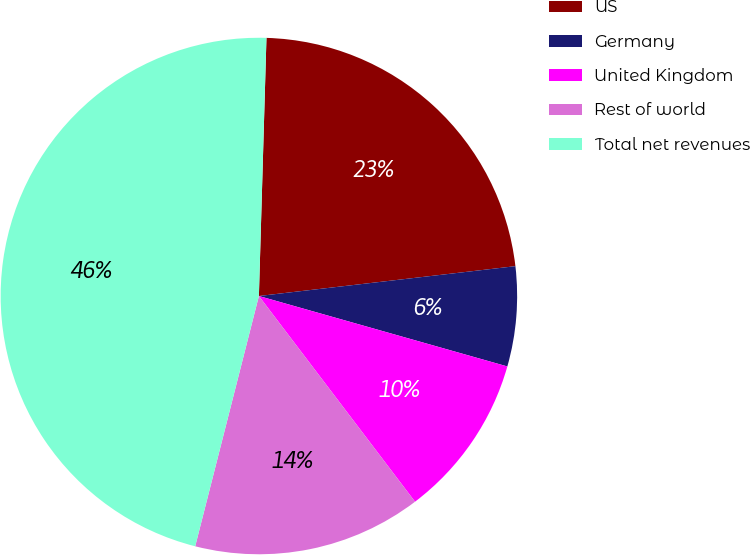Convert chart to OTSL. <chart><loc_0><loc_0><loc_500><loc_500><pie_chart><fcel>US<fcel>Germany<fcel>United Kingdom<fcel>Rest of world<fcel>Total net revenues<nl><fcel>22.69%<fcel>6.24%<fcel>10.27%<fcel>14.3%<fcel>46.5%<nl></chart> 